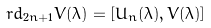<formula> <loc_0><loc_0><loc_500><loc_500>\ r d _ { 2 n + 1 } V ( \lambda ) = [ U _ { n } ( \lambda ) , V ( \lambda ) ]</formula> 